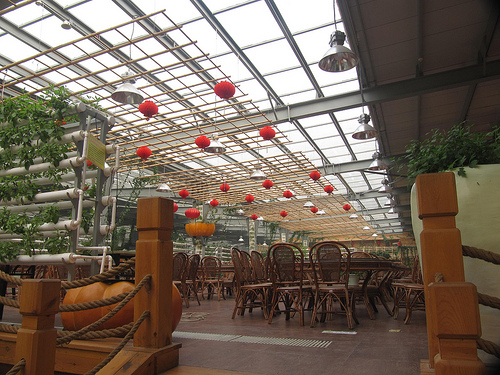<image>
Is there a plant above the wall? Yes. The plant is positioned above the wall in the vertical space, higher up in the scene. 